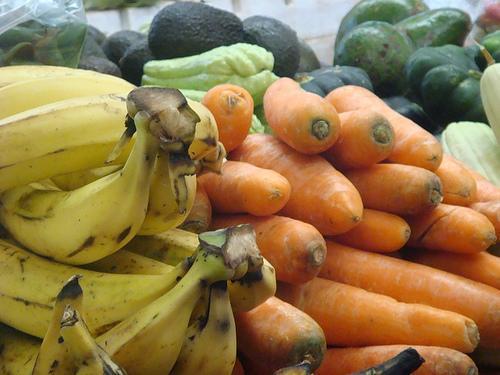How many bananas can you see?
Give a very brief answer. 5. 